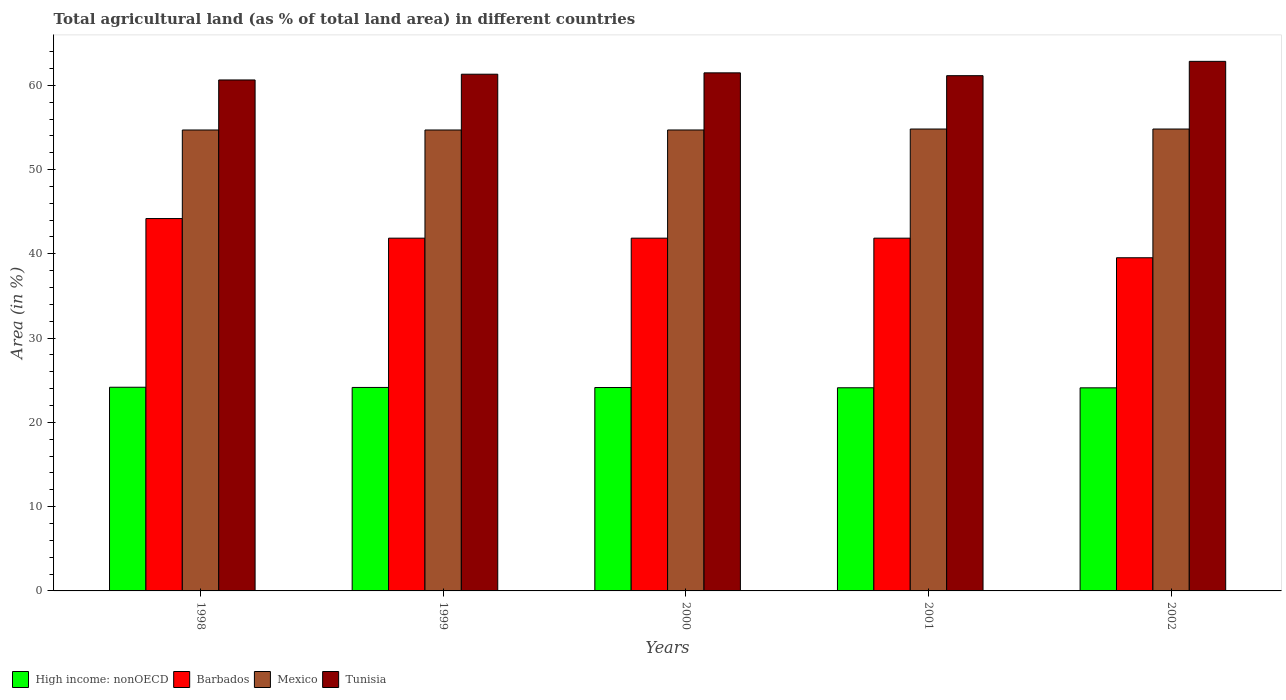How many groups of bars are there?
Offer a very short reply. 5. Are the number of bars per tick equal to the number of legend labels?
Your response must be concise. Yes. How many bars are there on the 2nd tick from the right?
Offer a terse response. 4. What is the percentage of agricultural land in Barbados in 2000?
Ensure brevity in your answer.  41.86. Across all years, what is the maximum percentage of agricultural land in Mexico?
Ensure brevity in your answer.  54.81. Across all years, what is the minimum percentage of agricultural land in Mexico?
Your answer should be compact. 54.7. In which year was the percentage of agricultural land in Mexico maximum?
Keep it short and to the point. 2001. What is the total percentage of agricultural land in Tunisia in the graph?
Your answer should be compact. 307.41. What is the difference between the percentage of agricultural land in Barbados in 2001 and that in 2002?
Your answer should be very brief. 2.33. What is the difference between the percentage of agricultural land in High income: nonOECD in 2000 and the percentage of agricultural land in Tunisia in 2001?
Your answer should be very brief. -37.01. What is the average percentage of agricultural land in Barbados per year?
Make the answer very short. 41.86. In the year 1999, what is the difference between the percentage of agricultural land in Mexico and percentage of agricultural land in Barbados?
Provide a succinct answer. 12.84. What is the ratio of the percentage of agricultural land in Tunisia in 1999 to that in 2000?
Your answer should be compact. 1. Is the percentage of agricultural land in High income: nonOECD in 1998 less than that in 2002?
Offer a terse response. No. Is the difference between the percentage of agricultural land in Mexico in 1999 and 2001 greater than the difference between the percentage of agricultural land in Barbados in 1999 and 2001?
Give a very brief answer. No. What is the difference between the highest and the second highest percentage of agricultural land in Barbados?
Make the answer very short. 2.33. What is the difference between the highest and the lowest percentage of agricultural land in Tunisia?
Provide a succinct answer. 2.21. Is the sum of the percentage of agricultural land in Barbados in 1998 and 2000 greater than the maximum percentage of agricultural land in Mexico across all years?
Your answer should be very brief. Yes. Is it the case that in every year, the sum of the percentage of agricultural land in Barbados and percentage of agricultural land in High income: nonOECD is greater than the sum of percentage of agricultural land in Tunisia and percentage of agricultural land in Mexico?
Give a very brief answer. No. What does the 4th bar from the left in 2001 represents?
Offer a very short reply. Tunisia. What does the 3rd bar from the right in 2002 represents?
Keep it short and to the point. Barbados. Is it the case that in every year, the sum of the percentage of agricultural land in Barbados and percentage of agricultural land in Tunisia is greater than the percentage of agricultural land in Mexico?
Your answer should be compact. Yes. Are all the bars in the graph horizontal?
Keep it short and to the point. No. What is the difference between two consecutive major ticks on the Y-axis?
Provide a short and direct response. 10. Does the graph contain grids?
Make the answer very short. No. What is the title of the graph?
Your answer should be very brief. Total agricultural land (as % of total land area) in different countries. What is the label or title of the Y-axis?
Ensure brevity in your answer.  Area (in %). What is the Area (in %) of High income: nonOECD in 1998?
Provide a short and direct response. 24.17. What is the Area (in %) in Barbados in 1998?
Offer a terse response. 44.19. What is the Area (in %) in Mexico in 1998?
Your answer should be compact. 54.7. What is the Area (in %) in Tunisia in 1998?
Provide a succinct answer. 60.63. What is the Area (in %) in High income: nonOECD in 1999?
Your response must be concise. 24.14. What is the Area (in %) of Barbados in 1999?
Provide a succinct answer. 41.86. What is the Area (in %) in Mexico in 1999?
Provide a succinct answer. 54.7. What is the Area (in %) in Tunisia in 1999?
Provide a short and direct response. 61.32. What is the Area (in %) in High income: nonOECD in 2000?
Provide a short and direct response. 24.14. What is the Area (in %) of Barbados in 2000?
Your response must be concise. 41.86. What is the Area (in %) in Mexico in 2000?
Provide a succinct answer. 54.7. What is the Area (in %) in Tunisia in 2000?
Give a very brief answer. 61.48. What is the Area (in %) of High income: nonOECD in 2001?
Your response must be concise. 24.11. What is the Area (in %) in Barbados in 2001?
Provide a succinct answer. 41.86. What is the Area (in %) of Mexico in 2001?
Provide a succinct answer. 54.81. What is the Area (in %) in Tunisia in 2001?
Your answer should be compact. 61.14. What is the Area (in %) of High income: nonOECD in 2002?
Provide a succinct answer. 24.1. What is the Area (in %) of Barbados in 2002?
Your answer should be very brief. 39.53. What is the Area (in %) in Mexico in 2002?
Offer a very short reply. 54.81. What is the Area (in %) of Tunisia in 2002?
Offer a terse response. 62.84. Across all years, what is the maximum Area (in %) of High income: nonOECD?
Your answer should be very brief. 24.17. Across all years, what is the maximum Area (in %) in Barbados?
Offer a very short reply. 44.19. Across all years, what is the maximum Area (in %) in Mexico?
Keep it short and to the point. 54.81. Across all years, what is the maximum Area (in %) of Tunisia?
Ensure brevity in your answer.  62.84. Across all years, what is the minimum Area (in %) of High income: nonOECD?
Keep it short and to the point. 24.1. Across all years, what is the minimum Area (in %) in Barbados?
Ensure brevity in your answer.  39.53. Across all years, what is the minimum Area (in %) of Mexico?
Provide a succinct answer. 54.7. Across all years, what is the minimum Area (in %) in Tunisia?
Offer a terse response. 60.63. What is the total Area (in %) in High income: nonOECD in the graph?
Give a very brief answer. 120.66. What is the total Area (in %) of Barbados in the graph?
Your response must be concise. 209.3. What is the total Area (in %) in Mexico in the graph?
Offer a terse response. 273.71. What is the total Area (in %) in Tunisia in the graph?
Provide a succinct answer. 307.41. What is the difference between the Area (in %) in High income: nonOECD in 1998 and that in 1999?
Make the answer very short. 0.02. What is the difference between the Area (in %) of Barbados in 1998 and that in 1999?
Your answer should be compact. 2.33. What is the difference between the Area (in %) of Mexico in 1998 and that in 1999?
Provide a succinct answer. -0. What is the difference between the Area (in %) of Tunisia in 1998 and that in 1999?
Your answer should be compact. -0.68. What is the difference between the Area (in %) of High income: nonOECD in 1998 and that in 2000?
Your answer should be very brief. 0.03. What is the difference between the Area (in %) of Barbados in 1998 and that in 2000?
Your response must be concise. 2.33. What is the difference between the Area (in %) of Mexico in 1998 and that in 2000?
Provide a succinct answer. -0. What is the difference between the Area (in %) in Tunisia in 1998 and that in 2000?
Give a very brief answer. -0.84. What is the difference between the Area (in %) of High income: nonOECD in 1998 and that in 2001?
Ensure brevity in your answer.  0.06. What is the difference between the Area (in %) of Barbados in 1998 and that in 2001?
Keep it short and to the point. 2.33. What is the difference between the Area (in %) in Mexico in 1998 and that in 2001?
Provide a short and direct response. -0.12. What is the difference between the Area (in %) in Tunisia in 1998 and that in 2001?
Your answer should be compact. -0.51. What is the difference between the Area (in %) in High income: nonOECD in 1998 and that in 2002?
Give a very brief answer. 0.07. What is the difference between the Area (in %) of Barbados in 1998 and that in 2002?
Offer a terse response. 4.65. What is the difference between the Area (in %) of Mexico in 1998 and that in 2002?
Give a very brief answer. -0.12. What is the difference between the Area (in %) in Tunisia in 1998 and that in 2002?
Make the answer very short. -2.21. What is the difference between the Area (in %) in High income: nonOECD in 1999 and that in 2000?
Offer a very short reply. 0.01. What is the difference between the Area (in %) of Mexico in 1999 and that in 2000?
Your answer should be compact. -0. What is the difference between the Area (in %) in Tunisia in 1999 and that in 2000?
Offer a very short reply. -0.16. What is the difference between the Area (in %) in High income: nonOECD in 1999 and that in 2001?
Keep it short and to the point. 0.04. What is the difference between the Area (in %) in Barbados in 1999 and that in 2001?
Offer a very short reply. 0. What is the difference between the Area (in %) of Mexico in 1999 and that in 2001?
Give a very brief answer. -0.12. What is the difference between the Area (in %) in Tunisia in 1999 and that in 2001?
Provide a succinct answer. 0.17. What is the difference between the Area (in %) of High income: nonOECD in 1999 and that in 2002?
Give a very brief answer. 0.05. What is the difference between the Area (in %) of Barbados in 1999 and that in 2002?
Offer a very short reply. 2.33. What is the difference between the Area (in %) in Mexico in 1999 and that in 2002?
Keep it short and to the point. -0.12. What is the difference between the Area (in %) of Tunisia in 1999 and that in 2002?
Make the answer very short. -1.53. What is the difference between the Area (in %) in High income: nonOECD in 2000 and that in 2001?
Your answer should be very brief. 0.03. What is the difference between the Area (in %) of Mexico in 2000 and that in 2001?
Offer a very short reply. -0.11. What is the difference between the Area (in %) of Tunisia in 2000 and that in 2001?
Provide a succinct answer. 0.33. What is the difference between the Area (in %) in High income: nonOECD in 2000 and that in 2002?
Give a very brief answer. 0.04. What is the difference between the Area (in %) in Barbados in 2000 and that in 2002?
Provide a succinct answer. 2.33. What is the difference between the Area (in %) of Mexico in 2000 and that in 2002?
Your answer should be very brief. -0.11. What is the difference between the Area (in %) in Tunisia in 2000 and that in 2002?
Keep it short and to the point. -1.36. What is the difference between the Area (in %) of High income: nonOECD in 2001 and that in 2002?
Give a very brief answer. 0.01. What is the difference between the Area (in %) of Barbados in 2001 and that in 2002?
Provide a short and direct response. 2.33. What is the difference between the Area (in %) of Tunisia in 2001 and that in 2002?
Give a very brief answer. -1.7. What is the difference between the Area (in %) of High income: nonOECD in 1998 and the Area (in %) of Barbados in 1999?
Provide a short and direct response. -17.69. What is the difference between the Area (in %) in High income: nonOECD in 1998 and the Area (in %) in Mexico in 1999?
Your response must be concise. -30.53. What is the difference between the Area (in %) in High income: nonOECD in 1998 and the Area (in %) in Tunisia in 1999?
Your answer should be very brief. -37.15. What is the difference between the Area (in %) of Barbados in 1998 and the Area (in %) of Mexico in 1999?
Keep it short and to the point. -10.51. What is the difference between the Area (in %) of Barbados in 1998 and the Area (in %) of Tunisia in 1999?
Offer a terse response. -17.13. What is the difference between the Area (in %) of Mexico in 1998 and the Area (in %) of Tunisia in 1999?
Offer a very short reply. -6.62. What is the difference between the Area (in %) in High income: nonOECD in 1998 and the Area (in %) in Barbados in 2000?
Ensure brevity in your answer.  -17.69. What is the difference between the Area (in %) of High income: nonOECD in 1998 and the Area (in %) of Mexico in 2000?
Offer a very short reply. -30.53. What is the difference between the Area (in %) of High income: nonOECD in 1998 and the Area (in %) of Tunisia in 2000?
Provide a succinct answer. -37.31. What is the difference between the Area (in %) of Barbados in 1998 and the Area (in %) of Mexico in 2000?
Offer a very short reply. -10.51. What is the difference between the Area (in %) of Barbados in 1998 and the Area (in %) of Tunisia in 2000?
Ensure brevity in your answer.  -17.29. What is the difference between the Area (in %) in Mexico in 1998 and the Area (in %) in Tunisia in 2000?
Provide a succinct answer. -6.78. What is the difference between the Area (in %) of High income: nonOECD in 1998 and the Area (in %) of Barbados in 2001?
Provide a succinct answer. -17.69. What is the difference between the Area (in %) in High income: nonOECD in 1998 and the Area (in %) in Mexico in 2001?
Your answer should be very brief. -30.64. What is the difference between the Area (in %) in High income: nonOECD in 1998 and the Area (in %) in Tunisia in 2001?
Ensure brevity in your answer.  -36.97. What is the difference between the Area (in %) in Barbados in 1998 and the Area (in %) in Mexico in 2001?
Offer a terse response. -10.62. What is the difference between the Area (in %) in Barbados in 1998 and the Area (in %) in Tunisia in 2001?
Make the answer very short. -16.96. What is the difference between the Area (in %) in Mexico in 1998 and the Area (in %) in Tunisia in 2001?
Your answer should be compact. -6.45. What is the difference between the Area (in %) in High income: nonOECD in 1998 and the Area (in %) in Barbados in 2002?
Offer a very short reply. -15.37. What is the difference between the Area (in %) in High income: nonOECD in 1998 and the Area (in %) in Mexico in 2002?
Your answer should be compact. -30.64. What is the difference between the Area (in %) of High income: nonOECD in 1998 and the Area (in %) of Tunisia in 2002?
Give a very brief answer. -38.67. What is the difference between the Area (in %) in Barbados in 1998 and the Area (in %) in Mexico in 2002?
Give a very brief answer. -10.62. What is the difference between the Area (in %) in Barbados in 1998 and the Area (in %) in Tunisia in 2002?
Provide a succinct answer. -18.66. What is the difference between the Area (in %) of Mexico in 1998 and the Area (in %) of Tunisia in 2002?
Provide a succinct answer. -8.15. What is the difference between the Area (in %) of High income: nonOECD in 1999 and the Area (in %) of Barbados in 2000?
Your answer should be compact. -17.72. What is the difference between the Area (in %) in High income: nonOECD in 1999 and the Area (in %) in Mexico in 2000?
Offer a terse response. -30.55. What is the difference between the Area (in %) in High income: nonOECD in 1999 and the Area (in %) in Tunisia in 2000?
Your answer should be very brief. -37.33. What is the difference between the Area (in %) in Barbados in 1999 and the Area (in %) in Mexico in 2000?
Ensure brevity in your answer.  -12.84. What is the difference between the Area (in %) in Barbados in 1999 and the Area (in %) in Tunisia in 2000?
Provide a succinct answer. -19.62. What is the difference between the Area (in %) of Mexico in 1999 and the Area (in %) of Tunisia in 2000?
Offer a very short reply. -6.78. What is the difference between the Area (in %) of High income: nonOECD in 1999 and the Area (in %) of Barbados in 2001?
Your answer should be compact. -17.72. What is the difference between the Area (in %) of High income: nonOECD in 1999 and the Area (in %) of Mexico in 2001?
Keep it short and to the point. -30.67. What is the difference between the Area (in %) in High income: nonOECD in 1999 and the Area (in %) in Tunisia in 2001?
Offer a terse response. -37. What is the difference between the Area (in %) in Barbados in 1999 and the Area (in %) in Mexico in 2001?
Keep it short and to the point. -12.95. What is the difference between the Area (in %) of Barbados in 1999 and the Area (in %) of Tunisia in 2001?
Give a very brief answer. -19.28. What is the difference between the Area (in %) in Mexico in 1999 and the Area (in %) in Tunisia in 2001?
Your answer should be very brief. -6.45. What is the difference between the Area (in %) in High income: nonOECD in 1999 and the Area (in %) in Barbados in 2002?
Your answer should be very brief. -15.39. What is the difference between the Area (in %) in High income: nonOECD in 1999 and the Area (in %) in Mexico in 2002?
Keep it short and to the point. -30.67. What is the difference between the Area (in %) in High income: nonOECD in 1999 and the Area (in %) in Tunisia in 2002?
Offer a terse response. -38.7. What is the difference between the Area (in %) of Barbados in 1999 and the Area (in %) of Mexico in 2002?
Provide a succinct answer. -12.95. What is the difference between the Area (in %) in Barbados in 1999 and the Area (in %) in Tunisia in 2002?
Provide a succinct answer. -20.98. What is the difference between the Area (in %) of Mexico in 1999 and the Area (in %) of Tunisia in 2002?
Offer a terse response. -8.15. What is the difference between the Area (in %) in High income: nonOECD in 2000 and the Area (in %) in Barbados in 2001?
Give a very brief answer. -17.72. What is the difference between the Area (in %) in High income: nonOECD in 2000 and the Area (in %) in Mexico in 2001?
Keep it short and to the point. -30.67. What is the difference between the Area (in %) of High income: nonOECD in 2000 and the Area (in %) of Tunisia in 2001?
Keep it short and to the point. -37.01. What is the difference between the Area (in %) of Barbados in 2000 and the Area (in %) of Mexico in 2001?
Ensure brevity in your answer.  -12.95. What is the difference between the Area (in %) of Barbados in 2000 and the Area (in %) of Tunisia in 2001?
Offer a very short reply. -19.28. What is the difference between the Area (in %) of Mexico in 2000 and the Area (in %) of Tunisia in 2001?
Keep it short and to the point. -6.44. What is the difference between the Area (in %) of High income: nonOECD in 2000 and the Area (in %) of Barbados in 2002?
Ensure brevity in your answer.  -15.4. What is the difference between the Area (in %) in High income: nonOECD in 2000 and the Area (in %) in Mexico in 2002?
Provide a succinct answer. -30.67. What is the difference between the Area (in %) in High income: nonOECD in 2000 and the Area (in %) in Tunisia in 2002?
Offer a terse response. -38.7. What is the difference between the Area (in %) of Barbados in 2000 and the Area (in %) of Mexico in 2002?
Keep it short and to the point. -12.95. What is the difference between the Area (in %) in Barbados in 2000 and the Area (in %) in Tunisia in 2002?
Your answer should be compact. -20.98. What is the difference between the Area (in %) in Mexico in 2000 and the Area (in %) in Tunisia in 2002?
Your response must be concise. -8.14. What is the difference between the Area (in %) in High income: nonOECD in 2001 and the Area (in %) in Barbados in 2002?
Ensure brevity in your answer.  -15.43. What is the difference between the Area (in %) of High income: nonOECD in 2001 and the Area (in %) of Mexico in 2002?
Offer a very short reply. -30.7. What is the difference between the Area (in %) in High income: nonOECD in 2001 and the Area (in %) in Tunisia in 2002?
Give a very brief answer. -38.73. What is the difference between the Area (in %) in Barbados in 2001 and the Area (in %) in Mexico in 2002?
Provide a succinct answer. -12.95. What is the difference between the Area (in %) of Barbados in 2001 and the Area (in %) of Tunisia in 2002?
Your answer should be compact. -20.98. What is the difference between the Area (in %) of Mexico in 2001 and the Area (in %) of Tunisia in 2002?
Your answer should be very brief. -8.03. What is the average Area (in %) in High income: nonOECD per year?
Give a very brief answer. 24.13. What is the average Area (in %) in Barbados per year?
Your answer should be compact. 41.86. What is the average Area (in %) of Mexico per year?
Keep it short and to the point. 54.74. What is the average Area (in %) of Tunisia per year?
Give a very brief answer. 61.48. In the year 1998, what is the difference between the Area (in %) in High income: nonOECD and Area (in %) in Barbados?
Make the answer very short. -20.02. In the year 1998, what is the difference between the Area (in %) in High income: nonOECD and Area (in %) in Mexico?
Your answer should be compact. -30.53. In the year 1998, what is the difference between the Area (in %) of High income: nonOECD and Area (in %) of Tunisia?
Give a very brief answer. -36.46. In the year 1998, what is the difference between the Area (in %) of Barbados and Area (in %) of Mexico?
Make the answer very short. -10.51. In the year 1998, what is the difference between the Area (in %) of Barbados and Area (in %) of Tunisia?
Keep it short and to the point. -16.45. In the year 1998, what is the difference between the Area (in %) of Mexico and Area (in %) of Tunisia?
Make the answer very short. -5.94. In the year 1999, what is the difference between the Area (in %) in High income: nonOECD and Area (in %) in Barbados?
Offer a very short reply. -17.72. In the year 1999, what is the difference between the Area (in %) of High income: nonOECD and Area (in %) of Mexico?
Your answer should be compact. -30.55. In the year 1999, what is the difference between the Area (in %) in High income: nonOECD and Area (in %) in Tunisia?
Offer a very short reply. -37.17. In the year 1999, what is the difference between the Area (in %) of Barbados and Area (in %) of Mexico?
Offer a very short reply. -12.84. In the year 1999, what is the difference between the Area (in %) of Barbados and Area (in %) of Tunisia?
Make the answer very short. -19.46. In the year 1999, what is the difference between the Area (in %) in Mexico and Area (in %) in Tunisia?
Your response must be concise. -6.62. In the year 2000, what is the difference between the Area (in %) in High income: nonOECD and Area (in %) in Barbados?
Make the answer very short. -17.72. In the year 2000, what is the difference between the Area (in %) in High income: nonOECD and Area (in %) in Mexico?
Offer a very short reply. -30.56. In the year 2000, what is the difference between the Area (in %) in High income: nonOECD and Area (in %) in Tunisia?
Ensure brevity in your answer.  -37.34. In the year 2000, what is the difference between the Area (in %) in Barbados and Area (in %) in Mexico?
Ensure brevity in your answer.  -12.84. In the year 2000, what is the difference between the Area (in %) in Barbados and Area (in %) in Tunisia?
Your response must be concise. -19.62. In the year 2000, what is the difference between the Area (in %) of Mexico and Area (in %) of Tunisia?
Keep it short and to the point. -6.78. In the year 2001, what is the difference between the Area (in %) in High income: nonOECD and Area (in %) in Barbados?
Your answer should be compact. -17.75. In the year 2001, what is the difference between the Area (in %) in High income: nonOECD and Area (in %) in Mexico?
Your response must be concise. -30.7. In the year 2001, what is the difference between the Area (in %) in High income: nonOECD and Area (in %) in Tunisia?
Ensure brevity in your answer.  -37.03. In the year 2001, what is the difference between the Area (in %) of Barbados and Area (in %) of Mexico?
Make the answer very short. -12.95. In the year 2001, what is the difference between the Area (in %) of Barbados and Area (in %) of Tunisia?
Ensure brevity in your answer.  -19.28. In the year 2001, what is the difference between the Area (in %) of Mexico and Area (in %) of Tunisia?
Your answer should be very brief. -6.33. In the year 2002, what is the difference between the Area (in %) in High income: nonOECD and Area (in %) in Barbados?
Give a very brief answer. -15.44. In the year 2002, what is the difference between the Area (in %) in High income: nonOECD and Area (in %) in Mexico?
Make the answer very short. -30.71. In the year 2002, what is the difference between the Area (in %) in High income: nonOECD and Area (in %) in Tunisia?
Provide a short and direct response. -38.74. In the year 2002, what is the difference between the Area (in %) of Barbados and Area (in %) of Mexico?
Keep it short and to the point. -15.28. In the year 2002, what is the difference between the Area (in %) of Barbados and Area (in %) of Tunisia?
Provide a succinct answer. -23.31. In the year 2002, what is the difference between the Area (in %) in Mexico and Area (in %) in Tunisia?
Your answer should be compact. -8.03. What is the ratio of the Area (in %) of Barbados in 1998 to that in 1999?
Your answer should be very brief. 1.06. What is the ratio of the Area (in %) of Mexico in 1998 to that in 1999?
Provide a succinct answer. 1. What is the ratio of the Area (in %) of Tunisia in 1998 to that in 1999?
Give a very brief answer. 0.99. What is the ratio of the Area (in %) of Barbados in 1998 to that in 2000?
Provide a short and direct response. 1.06. What is the ratio of the Area (in %) of Tunisia in 1998 to that in 2000?
Your response must be concise. 0.99. What is the ratio of the Area (in %) in Barbados in 1998 to that in 2001?
Give a very brief answer. 1.06. What is the ratio of the Area (in %) of Mexico in 1998 to that in 2001?
Make the answer very short. 1. What is the ratio of the Area (in %) of Tunisia in 1998 to that in 2001?
Your answer should be very brief. 0.99. What is the ratio of the Area (in %) of High income: nonOECD in 1998 to that in 2002?
Your answer should be very brief. 1. What is the ratio of the Area (in %) of Barbados in 1998 to that in 2002?
Provide a short and direct response. 1.12. What is the ratio of the Area (in %) in Mexico in 1998 to that in 2002?
Give a very brief answer. 1. What is the ratio of the Area (in %) of Tunisia in 1998 to that in 2002?
Ensure brevity in your answer.  0.96. What is the ratio of the Area (in %) of Mexico in 1999 to that in 2000?
Provide a short and direct response. 1. What is the ratio of the Area (in %) of Tunisia in 1999 to that in 2000?
Offer a very short reply. 1. What is the ratio of the Area (in %) in High income: nonOECD in 1999 to that in 2001?
Provide a succinct answer. 1. What is the ratio of the Area (in %) of Mexico in 1999 to that in 2001?
Provide a succinct answer. 1. What is the ratio of the Area (in %) in Barbados in 1999 to that in 2002?
Provide a short and direct response. 1.06. What is the ratio of the Area (in %) in Mexico in 1999 to that in 2002?
Provide a short and direct response. 1. What is the ratio of the Area (in %) of Tunisia in 1999 to that in 2002?
Offer a terse response. 0.98. What is the ratio of the Area (in %) of High income: nonOECD in 2000 to that in 2001?
Offer a very short reply. 1. What is the ratio of the Area (in %) in Mexico in 2000 to that in 2001?
Keep it short and to the point. 1. What is the ratio of the Area (in %) in Barbados in 2000 to that in 2002?
Offer a very short reply. 1.06. What is the ratio of the Area (in %) of Mexico in 2000 to that in 2002?
Provide a succinct answer. 1. What is the ratio of the Area (in %) of Tunisia in 2000 to that in 2002?
Provide a short and direct response. 0.98. What is the ratio of the Area (in %) in High income: nonOECD in 2001 to that in 2002?
Ensure brevity in your answer.  1. What is the ratio of the Area (in %) in Barbados in 2001 to that in 2002?
Make the answer very short. 1.06. What is the ratio of the Area (in %) of Mexico in 2001 to that in 2002?
Your answer should be very brief. 1. What is the ratio of the Area (in %) in Tunisia in 2001 to that in 2002?
Keep it short and to the point. 0.97. What is the difference between the highest and the second highest Area (in %) of High income: nonOECD?
Your answer should be compact. 0.02. What is the difference between the highest and the second highest Area (in %) in Barbados?
Your answer should be compact. 2.33. What is the difference between the highest and the second highest Area (in %) of Mexico?
Provide a succinct answer. 0. What is the difference between the highest and the second highest Area (in %) of Tunisia?
Keep it short and to the point. 1.36. What is the difference between the highest and the lowest Area (in %) of High income: nonOECD?
Ensure brevity in your answer.  0.07. What is the difference between the highest and the lowest Area (in %) in Barbados?
Make the answer very short. 4.65. What is the difference between the highest and the lowest Area (in %) of Mexico?
Give a very brief answer. 0.12. What is the difference between the highest and the lowest Area (in %) in Tunisia?
Your answer should be compact. 2.21. 